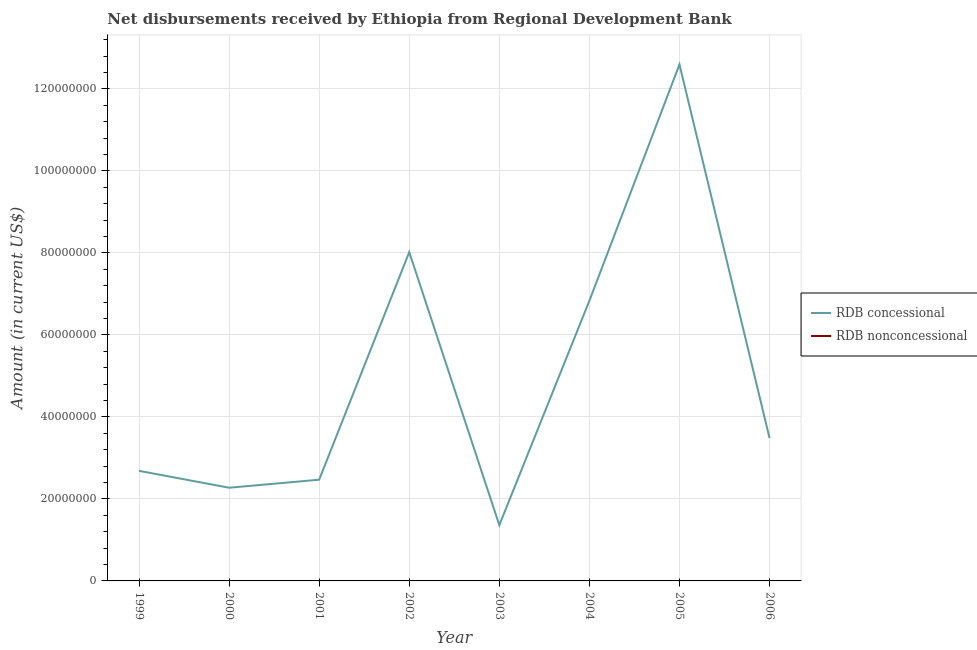How many different coloured lines are there?
Offer a terse response. 1. Does the line corresponding to net concessional disbursements from rdb intersect with the line corresponding to net non concessional disbursements from rdb?
Your answer should be compact. No. Across all years, what is the maximum net concessional disbursements from rdb?
Give a very brief answer. 1.26e+08. In which year was the net concessional disbursements from rdb maximum?
Keep it short and to the point. 2005. What is the total net concessional disbursements from rdb in the graph?
Make the answer very short. 3.97e+08. What is the difference between the net concessional disbursements from rdb in 2000 and that in 2001?
Ensure brevity in your answer.  -1.95e+06. What is the difference between the net non concessional disbursements from rdb in 2001 and the net concessional disbursements from rdb in 2002?
Your response must be concise. -8.02e+07. What is the average net concessional disbursements from rdb per year?
Your response must be concise. 4.96e+07. In how many years, is the net concessional disbursements from rdb greater than 4000000 US$?
Provide a succinct answer. 8. What is the ratio of the net concessional disbursements from rdb in 2002 to that in 2006?
Your answer should be compact. 2.3. Is the net concessional disbursements from rdb in 1999 less than that in 2005?
Offer a very short reply. Yes. What is the difference between the highest and the second highest net concessional disbursements from rdb?
Keep it short and to the point. 4.58e+07. What is the difference between the highest and the lowest net concessional disbursements from rdb?
Your response must be concise. 1.12e+08. In how many years, is the net non concessional disbursements from rdb greater than the average net non concessional disbursements from rdb taken over all years?
Make the answer very short. 0. Is the sum of the net concessional disbursements from rdb in 2000 and 2002 greater than the maximum net non concessional disbursements from rdb across all years?
Offer a very short reply. Yes. Is the net concessional disbursements from rdb strictly less than the net non concessional disbursements from rdb over the years?
Ensure brevity in your answer.  No. How many lines are there?
Provide a succinct answer. 1. How many years are there in the graph?
Make the answer very short. 8. Are the values on the major ticks of Y-axis written in scientific E-notation?
Ensure brevity in your answer.  No. Where does the legend appear in the graph?
Offer a terse response. Center right. How many legend labels are there?
Your response must be concise. 2. What is the title of the graph?
Keep it short and to the point. Net disbursements received by Ethiopia from Regional Development Bank. What is the label or title of the X-axis?
Your answer should be very brief. Year. What is the label or title of the Y-axis?
Provide a succinct answer. Amount (in current US$). What is the Amount (in current US$) of RDB concessional in 1999?
Ensure brevity in your answer.  2.68e+07. What is the Amount (in current US$) in RDB nonconcessional in 1999?
Make the answer very short. 0. What is the Amount (in current US$) of RDB concessional in 2000?
Your response must be concise. 2.27e+07. What is the Amount (in current US$) in RDB nonconcessional in 2000?
Your response must be concise. 0. What is the Amount (in current US$) in RDB concessional in 2001?
Ensure brevity in your answer.  2.47e+07. What is the Amount (in current US$) of RDB nonconcessional in 2001?
Make the answer very short. 0. What is the Amount (in current US$) in RDB concessional in 2002?
Your answer should be compact. 8.02e+07. What is the Amount (in current US$) of RDB nonconcessional in 2002?
Offer a terse response. 0. What is the Amount (in current US$) of RDB concessional in 2003?
Your answer should be compact. 1.36e+07. What is the Amount (in current US$) in RDB concessional in 2004?
Make the answer very short. 6.83e+07. What is the Amount (in current US$) of RDB concessional in 2005?
Your answer should be compact. 1.26e+08. What is the Amount (in current US$) in RDB concessional in 2006?
Offer a very short reply. 3.48e+07. What is the Amount (in current US$) in RDB nonconcessional in 2006?
Ensure brevity in your answer.  0. Across all years, what is the maximum Amount (in current US$) of RDB concessional?
Provide a succinct answer. 1.26e+08. Across all years, what is the minimum Amount (in current US$) of RDB concessional?
Your response must be concise. 1.36e+07. What is the total Amount (in current US$) in RDB concessional in the graph?
Your response must be concise. 3.97e+08. What is the difference between the Amount (in current US$) of RDB concessional in 1999 and that in 2000?
Keep it short and to the point. 4.12e+06. What is the difference between the Amount (in current US$) in RDB concessional in 1999 and that in 2001?
Give a very brief answer. 2.16e+06. What is the difference between the Amount (in current US$) of RDB concessional in 1999 and that in 2002?
Your answer should be compact. -5.33e+07. What is the difference between the Amount (in current US$) of RDB concessional in 1999 and that in 2003?
Your answer should be very brief. 1.32e+07. What is the difference between the Amount (in current US$) of RDB concessional in 1999 and that in 2004?
Give a very brief answer. -4.15e+07. What is the difference between the Amount (in current US$) in RDB concessional in 1999 and that in 2005?
Ensure brevity in your answer.  -9.91e+07. What is the difference between the Amount (in current US$) of RDB concessional in 1999 and that in 2006?
Keep it short and to the point. -7.98e+06. What is the difference between the Amount (in current US$) in RDB concessional in 2000 and that in 2001?
Your answer should be compact. -1.95e+06. What is the difference between the Amount (in current US$) of RDB concessional in 2000 and that in 2002?
Provide a succinct answer. -5.75e+07. What is the difference between the Amount (in current US$) in RDB concessional in 2000 and that in 2003?
Make the answer very short. 9.12e+06. What is the difference between the Amount (in current US$) of RDB concessional in 2000 and that in 2004?
Ensure brevity in your answer.  -4.56e+07. What is the difference between the Amount (in current US$) of RDB concessional in 2000 and that in 2005?
Offer a terse response. -1.03e+08. What is the difference between the Amount (in current US$) in RDB concessional in 2000 and that in 2006?
Your answer should be compact. -1.21e+07. What is the difference between the Amount (in current US$) in RDB concessional in 2001 and that in 2002?
Ensure brevity in your answer.  -5.55e+07. What is the difference between the Amount (in current US$) of RDB concessional in 2001 and that in 2003?
Ensure brevity in your answer.  1.11e+07. What is the difference between the Amount (in current US$) in RDB concessional in 2001 and that in 2004?
Make the answer very short. -4.36e+07. What is the difference between the Amount (in current US$) of RDB concessional in 2001 and that in 2005?
Make the answer very short. -1.01e+08. What is the difference between the Amount (in current US$) in RDB concessional in 2001 and that in 2006?
Offer a terse response. -1.01e+07. What is the difference between the Amount (in current US$) in RDB concessional in 2002 and that in 2003?
Offer a very short reply. 6.66e+07. What is the difference between the Amount (in current US$) of RDB concessional in 2002 and that in 2004?
Provide a short and direct response. 1.19e+07. What is the difference between the Amount (in current US$) of RDB concessional in 2002 and that in 2005?
Your answer should be very brief. -4.58e+07. What is the difference between the Amount (in current US$) of RDB concessional in 2002 and that in 2006?
Provide a short and direct response. 4.54e+07. What is the difference between the Amount (in current US$) of RDB concessional in 2003 and that in 2004?
Provide a succinct answer. -5.47e+07. What is the difference between the Amount (in current US$) in RDB concessional in 2003 and that in 2005?
Ensure brevity in your answer.  -1.12e+08. What is the difference between the Amount (in current US$) in RDB concessional in 2003 and that in 2006?
Give a very brief answer. -2.12e+07. What is the difference between the Amount (in current US$) of RDB concessional in 2004 and that in 2005?
Your answer should be very brief. -5.76e+07. What is the difference between the Amount (in current US$) of RDB concessional in 2004 and that in 2006?
Offer a terse response. 3.35e+07. What is the difference between the Amount (in current US$) of RDB concessional in 2005 and that in 2006?
Give a very brief answer. 9.11e+07. What is the average Amount (in current US$) of RDB concessional per year?
Ensure brevity in your answer.  4.96e+07. What is the average Amount (in current US$) of RDB nonconcessional per year?
Your answer should be compact. 0. What is the ratio of the Amount (in current US$) of RDB concessional in 1999 to that in 2000?
Your response must be concise. 1.18. What is the ratio of the Amount (in current US$) of RDB concessional in 1999 to that in 2001?
Your answer should be compact. 1.09. What is the ratio of the Amount (in current US$) of RDB concessional in 1999 to that in 2002?
Your response must be concise. 0.33. What is the ratio of the Amount (in current US$) in RDB concessional in 1999 to that in 2003?
Your response must be concise. 1.97. What is the ratio of the Amount (in current US$) of RDB concessional in 1999 to that in 2004?
Offer a terse response. 0.39. What is the ratio of the Amount (in current US$) in RDB concessional in 1999 to that in 2005?
Your response must be concise. 0.21. What is the ratio of the Amount (in current US$) in RDB concessional in 1999 to that in 2006?
Your answer should be very brief. 0.77. What is the ratio of the Amount (in current US$) in RDB concessional in 2000 to that in 2001?
Provide a succinct answer. 0.92. What is the ratio of the Amount (in current US$) in RDB concessional in 2000 to that in 2002?
Offer a terse response. 0.28. What is the ratio of the Amount (in current US$) of RDB concessional in 2000 to that in 2003?
Make the answer very short. 1.67. What is the ratio of the Amount (in current US$) of RDB concessional in 2000 to that in 2004?
Make the answer very short. 0.33. What is the ratio of the Amount (in current US$) in RDB concessional in 2000 to that in 2005?
Provide a succinct answer. 0.18. What is the ratio of the Amount (in current US$) of RDB concessional in 2000 to that in 2006?
Make the answer very short. 0.65. What is the ratio of the Amount (in current US$) in RDB concessional in 2001 to that in 2002?
Your answer should be very brief. 0.31. What is the ratio of the Amount (in current US$) in RDB concessional in 2001 to that in 2003?
Give a very brief answer. 1.81. What is the ratio of the Amount (in current US$) in RDB concessional in 2001 to that in 2004?
Your response must be concise. 0.36. What is the ratio of the Amount (in current US$) in RDB concessional in 2001 to that in 2005?
Your answer should be very brief. 0.2. What is the ratio of the Amount (in current US$) in RDB concessional in 2001 to that in 2006?
Provide a short and direct response. 0.71. What is the ratio of the Amount (in current US$) in RDB concessional in 2002 to that in 2003?
Make the answer very short. 5.89. What is the ratio of the Amount (in current US$) in RDB concessional in 2002 to that in 2004?
Provide a short and direct response. 1.17. What is the ratio of the Amount (in current US$) of RDB concessional in 2002 to that in 2005?
Provide a succinct answer. 0.64. What is the ratio of the Amount (in current US$) of RDB concessional in 2002 to that in 2006?
Provide a short and direct response. 2.3. What is the ratio of the Amount (in current US$) of RDB concessional in 2003 to that in 2004?
Your answer should be very brief. 0.2. What is the ratio of the Amount (in current US$) in RDB concessional in 2003 to that in 2005?
Make the answer very short. 0.11. What is the ratio of the Amount (in current US$) of RDB concessional in 2003 to that in 2006?
Keep it short and to the point. 0.39. What is the ratio of the Amount (in current US$) of RDB concessional in 2004 to that in 2005?
Offer a very short reply. 0.54. What is the ratio of the Amount (in current US$) in RDB concessional in 2004 to that in 2006?
Keep it short and to the point. 1.96. What is the ratio of the Amount (in current US$) of RDB concessional in 2005 to that in 2006?
Your response must be concise. 3.62. What is the difference between the highest and the second highest Amount (in current US$) of RDB concessional?
Provide a succinct answer. 4.58e+07. What is the difference between the highest and the lowest Amount (in current US$) of RDB concessional?
Offer a very short reply. 1.12e+08. 